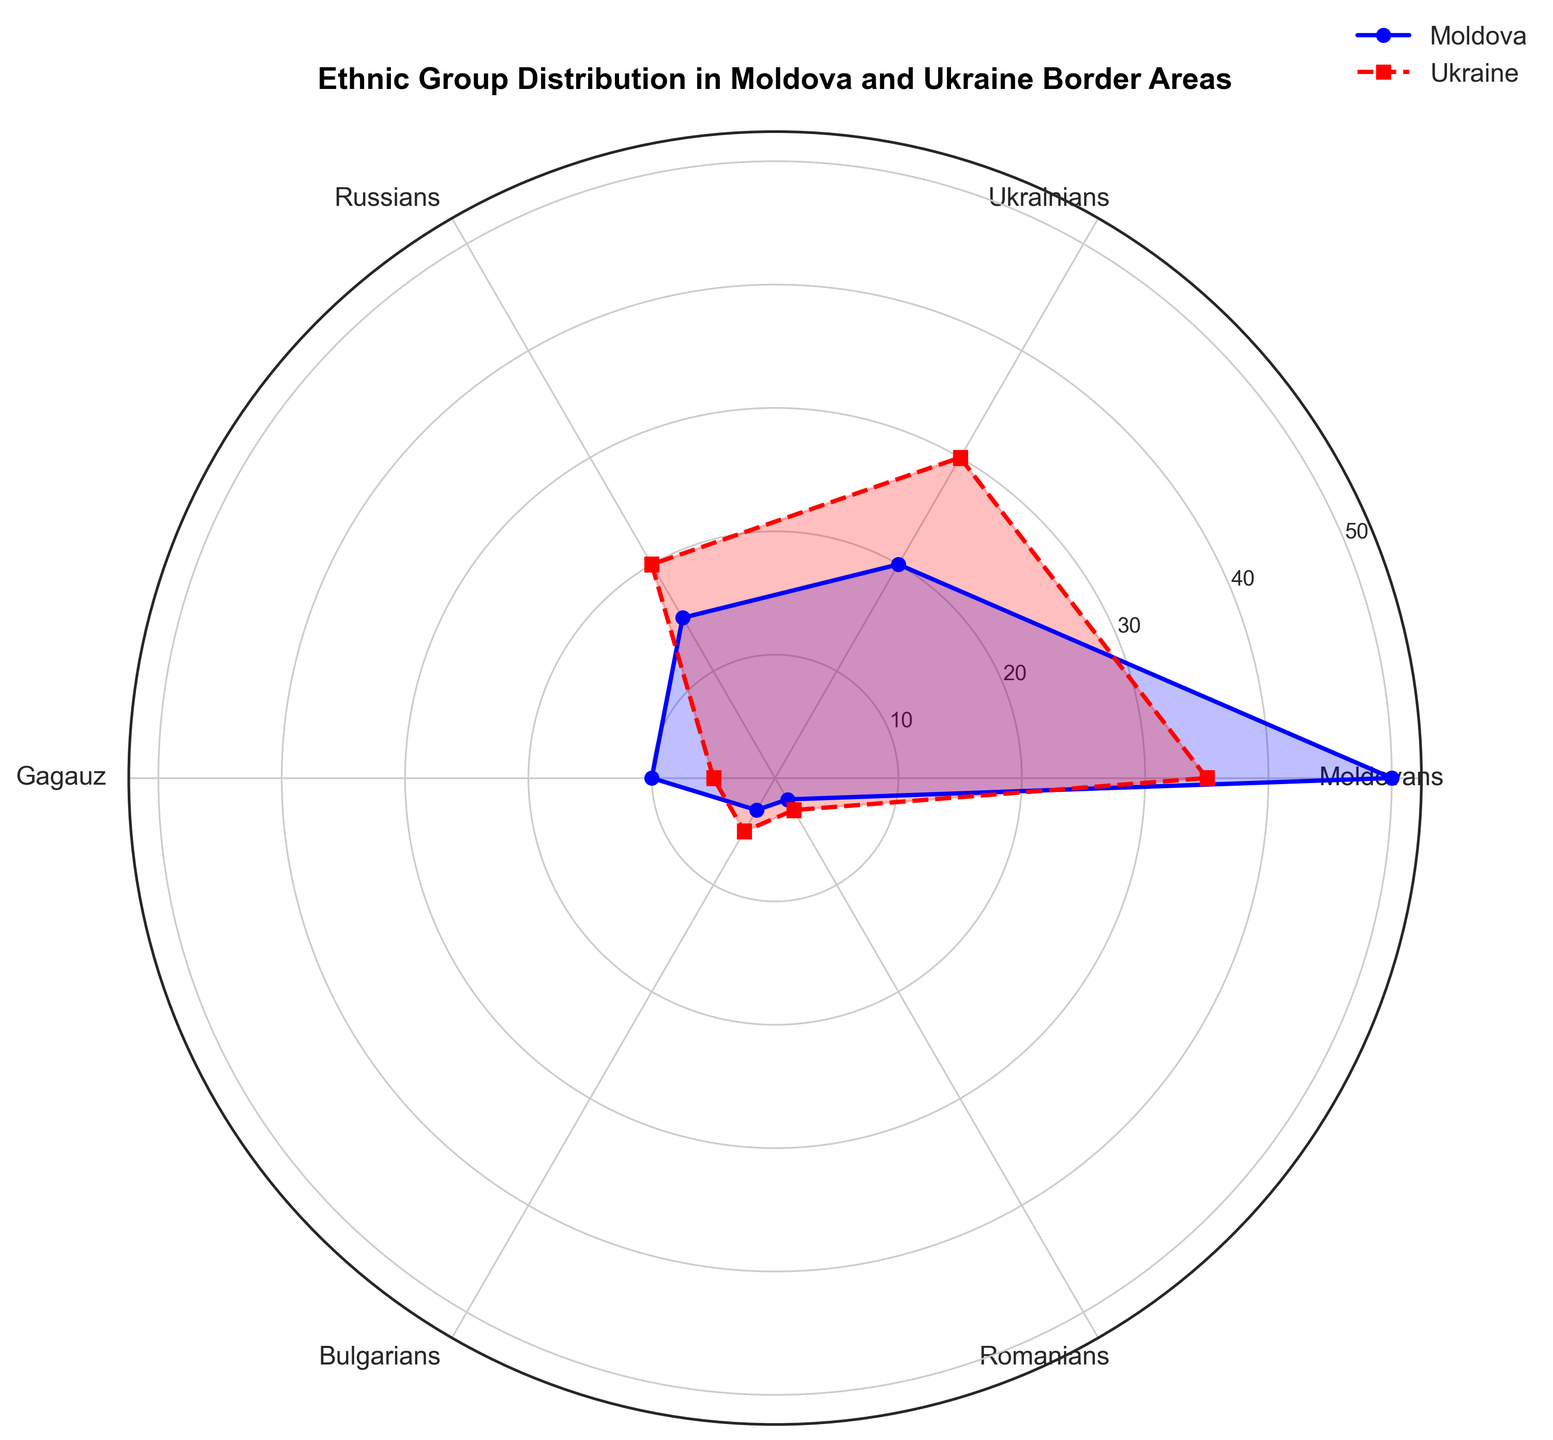Which ethnic group has the highest percentage in the Moldova border area? By observing the radar chart, the group with the highest value along the Moldova line (blue) can be identified. Moldovans have the highest point on the radar chart compared to other ethnic groups.
Answer: Moldovans Which ethnic group has the smallest percentage in the Ukraine border area? By examining the radar chart, the ethnic group with the lowest value along the Ukraine line (red) needs to be identified. Romanians have the smallest percentage in the Ukraine border area.
Answer: Romanians Are there more Moldovans in the Moldova border area than Ukrainians in the Ukraine border area? Compare the heights of the Moldovan percentage in the Moldova border area (blue) and the Ukrainian percentage in the Ukraine border area (red). Moldovans in the Moldova border area are 50%, while Ukrainians in the Ukraine border area are 30%.
Answer: Yes What's the combined percentage of Russians and Gagauz in the Moldova border area? Add the percentages of Russians and Gagauz in the Moldova border area from the chart: 15% (Russians) + 10% (Gagauz) = 25%.
Answer: 25% Which ethnic group has a greater percentage discrepancy between Moldova and Ukraine border areas, Gagauz or Bulgarians? Compare the percentage differences for Gagauz (10% in Moldova - 5% in Ukraine = 5%) and Bulgarians (3% in Moldova - 5% in Ukraine = 2%). The greater discrepancy is for Gagauz.
Answer: Gagauz How does the percentage of Bulgarians in Moldova compare to their percentage in Ukraine? Look at the values for Bulgarians in both areas on the radar chart. Bulgarians have a higher percentage in the Ukraine border area (5%) compared to the Moldova border area (3%).
Answer: Higher in Ukraine Is the sum of the percentage of Moldovans and Russians in Moldova greater than the overall percentage in Ukraine for any other single ethnic group? Calculate the sum of Moldovans and Russians in Moldova (50% + 15% = 65%) and compare it to each ethnic group’s percentage in Ukraine. For instance, the highest in Ukraine is Moldovans at 35%. 65% is higher than each single group's percentage in Ukraine.
Answer: Yes Which ethnic group has the same relative position in both Moldova and Ukraine? Look for ethnic groups that are positioned similarly in terms of their percentage values in both old and red parts of the radar chart. Bulgarians, having similar close values, have nearly the same relative position.
Answer: Bulgarians 